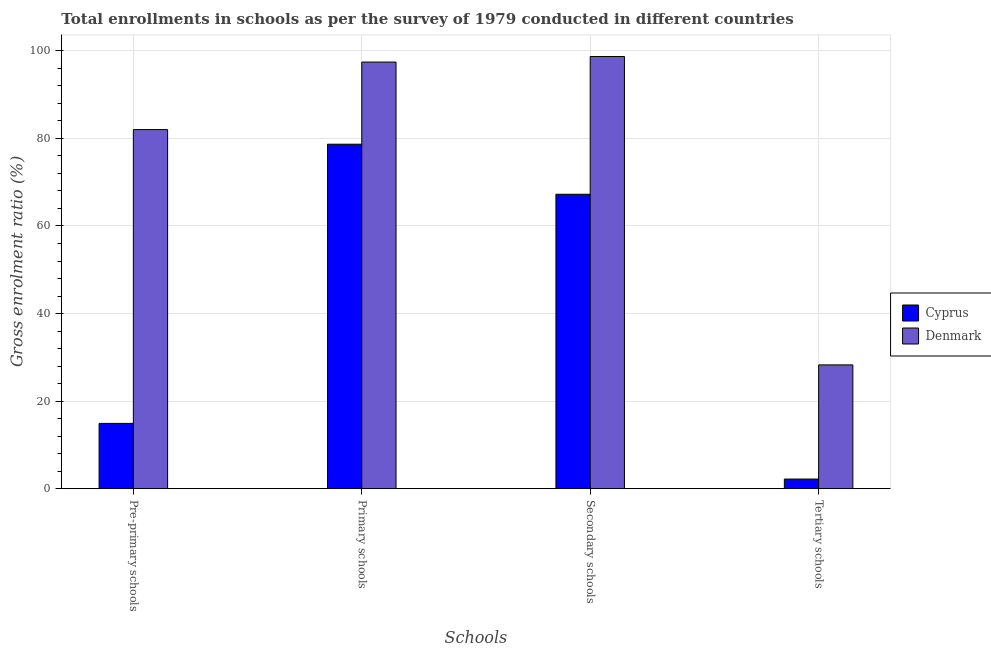Are the number of bars on each tick of the X-axis equal?
Make the answer very short. Yes. How many bars are there on the 3rd tick from the left?
Your response must be concise. 2. How many bars are there on the 1st tick from the right?
Ensure brevity in your answer.  2. What is the label of the 1st group of bars from the left?
Ensure brevity in your answer.  Pre-primary schools. What is the gross enrolment ratio in primary schools in Denmark?
Your answer should be very brief. 97.44. Across all countries, what is the maximum gross enrolment ratio in secondary schools?
Your response must be concise. 98.72. Across all countries, what is the minimum gross enrolment ratio in secondary schools?
Your answer should be very brief. 67.25. In which country was the gross enrolment ratio in tertiary schools maximum?
Provide a short and direct response. Denmark. In which country was the gross enrolment ratio in primary schools minimum?
Ensure brevity in your answer.  Cyprus. What is the total gross enrolment ratio in tertiary schools in the graph?
Provide a succinct answer. 30.47. What is the difference between the gross enrolment ratio in tertiary schools in Cyprus and that in Denmark?
Give a very brief answer. -26.08. What is the difference between the gross enrolment ratio in tertiary schools in Denmark and the gross enrolment ratio in primary schools in Cyprus?
Provide a succinct answer. -50.4. What is the average gross enrolment ratio in secondary schools per country?
Give a very brief answer. 82.98. What is the difference between the gross enrolment ratio in primary schools and gross enrolment ratio in secondary schools in Denmark?
Provide a short and direct response. -1.27. What is the ratio of the gross enrolment ratio in primary schools in Cyprus to that in Denmark?
Your answer should be very brief. 0.81. Is the difference between the gross enrolment ratio in primary schools in Cyprus and Denmark greater than the difference between the gross enrolment ratio in pre-primary schools in Cyprus and Denmark?
Keep it short and to the point. Yes. What is the difference between the highest and the second highest gross enrolment ratio in secondary schools?
Ensure brevity in your answer.  31.47. What is the difference between the highest and the lowest gross enrolment ratio in primary schools?
Your answer should be very brief. 18.77. In how many countries, is the gross enrolment ratio in secondary schools greater than the average gross enrolment ratio in secondary schools taken over all countries?
Give a very brief answer. 1. Is it the case that in every country, the sum of the gross enrolment ratio in tertiary schools and gross enrolment ratio in primary schools is greater than the sum of gross enrolment ratio in pre-primary schools and gross enrolment ratio in secondary schools?
Your response must be concise. No. What does the 1st bar from the right in Tertiary schools represents?
Your answer should be compact. Denmark. Is it the case that in every country, the sum of the gross enrolment ratio in pre-primary schools and gross enrolment ratio in primary schools is greater than the gross enrolment ratio in secondary schools?
Your response must be concise. Yes. Does the graph contain any zero values?
Your answer should be very brief. No. Where does the legend appear in the graph?
Your answer should be very brief. Center right. How are the legend labels stacked?
Offer a very short reply. Vertical. What is the title of the graph?
Keep it short and to the point. Total enrollments in schools as per the survey of 1979 conducted in different countries. Does "Greenland" appear as one of the legend labels in the graph?
Your answer should be very brief. No. What is the label or title of the X-axis?
Your answer should be compact. Schools. What is the Gross enrolment ratio (%) in Cyprus in Pre-primary schools?
Ensure brevity in your answer.  14.91. What is the Gross enrolment ratio (%) in Denmark in Pre-primary schools?
Your response must be concise. 82.02. What is the Gross enrolment ratio (%) of Cyprus in Primary schools?
Your response must be concise. 78.68. What is the Gross enrolment ratio (%) in Denmark in Primary schools?
Give a very brief answer. 97.44. What is the Gross enrolment ratio (%) in Cyprus in Secondary schools?
Provide a short and direct response. 67.25. What is the Gross enrolment ratio (%) in Denmark in Secondary schools?
Offer a terse response. 98.72. What is the Gross enrolment ratio (%) of Cyprus in Tertiary schools?
Offer a terse response. 2.2. What is the Gross enrolment ratio (%) of Denmark in Tertiary schools?
Your answer should be compact. 28.27. Across all Schools, what is the maximum Gross enrolment ratio (%) of Cyprus?
Your answer should be very brief. 78.68. Across all Schools, what is the maximum Gross enrolment ratio (%) in Denmark?
Give a very brief answer. 98.72. Across all Schools, what is the minimum Gross enrolment ratio (%) in Cyprus?
Offer a terse response. 2.2. Across all Schools, what is the minimum Gross enrolment ratio (%) in Denmark?
Ensure brevity in your answer.  28.27. What is the total Gross enrolment ratio (%) in Cyprus in the graph?
Your answer should be compact. 163.03. What is the total Gross enrolment ratio (%) of Denmark in the graph?
Provide a succinct answer. 306.45. What is the difference between the Gross enrolment ratio (%) of Cyprus in Pre-primary schools and that in Primary schools?
Provide a succinct answer. -63.77. What is the difference between the Gross enrolment ratio (%) of Denmark in Pre-primary schools and that in Primary schools?
Provide a succinct answer. -15.42. What is the difference between the Gross enrolment ratio (%) of Cyprus in Pre-primary schools and that in Secondary schools?
Your response must be concise. -52.34. What is the difference between the Gross enrolment ratio (%) in Denmark in Pre-primary schools and that in Secondary schools?
Your response must be concise. -16.7. What is the difference between the Gross enrolment ratio (%) of Cyprus in Pre-primary schools and that in Tertiary schools?
Provide a short and direct response. 12.71. What is the difference between the Gross enrolment ratio (%) of Denmark in Pre-primary schools and that in Tertiary schools?
Offer a very short reply. 53.74. What is the difference between the Gross enrolment ratio (%) in Cyprus in Primary schools and that in Secondary schools?
Keep it short and to the point. 11.43. What is the difference between the Gross enrolment ratio (%) in Denmark in Primary schools and that in Secondary schools?
Offer a terse response. -1.27. What is the difference between the Gross enrolment ratio (%) of Cyprus in Primary schools and that in Tertiary schools?
Make the answer very short. 76.48. What is the difference between the Gross enrolment ratio (%) in Denmark in Primary schools and that in Tertiary schools?
Your answer should be compact. 69.17. What is the difference between the Gross enrolment ratio (%) of Cyprus in Secondary schools and that in Tertiary schools?
Make the answer very short. 65.05. What is the difference between the Gross enrolment ratio (%) in Denmark in Secondary schools and that in Tertiary schools?
Your response must be concise. 70.44. What is the difference between the Gross enrolment ratio (%) of Cyprus in Pre-primary schools and the Gross enrolment ratio (%) of Denmark in Primary schools?
Keep it short and to the point. -82.54. What is the difference between the Gross enrolment ratio (%) of Cyprus in Pre-primary schools and the Gross enrolment ratio (%) of Denmark in Secondary schools?
Provide a short and direct response. -83.81. What is the difference between the Gross enrolment ratio (%) in Cyprus in Pre-primary schools and the Gross enrolment ratio (%) in Denmark in Tertiary schools?
Provide a short and direct response. -13.37. What is the difference between the Gross enrolment ratio (%) in Cyprus in Primary schools and the Gross enrolment ratio (%) in Denmark in Secondary schools?
Give a very brief answer. -20.04. What is the difference between the Gross enrolment ratio (%) in Cyprus in Primary schools and the Gross enrolment ratio (%) in Denmark in Tertiary schools?
Ensure brevity in your answer.  50.4. What is the difference between the Gross enrolment ratio (%) in Cyprus in Secondary schools and the Gross enrolment ratio (%) in Denmark in Tertiary schools?
Provide a succinct answer. 38.97. What is the average Gross enrolment ratio (%) of Cyprus per Schools?
Your response must be concise. 40.76. What is the average Gross enrolment ratio (%) of Denmark per Schools?
Provide a short and direct response. 76.61. What is the difference between the Gross enrolment ratio (%) in Cyprus and Gross enrolment ratio (%) in Denmark in Pre-primary schools?
Provide a short and direct response. -67.11. What is the difference between the Gross enrolment ratio (%) of Cyprus and Gross enrolment ratio (%) of Denmark in Primary schools?
Your answer should be compact. -18.77. What is the difference between the Gross enrolment ratio (%) of Cyprus and Gross enrolment ratio (%) of Denmark in Secondary schools?
Keep it short and to the point. -31.47. What is the difference between the Gross enrolment ratio (%) of Cyprus and Gross enrolment ratio (%) of Denmark in Tertiary schools?
Make the answer very short. -26.08. What is the ratio of the Gross enrolment ratio (%) in Cyprus in Pre-primary schools to that in Primary schools?
Provide a short and direct response. 0.19. What is the ratio of the Gross enrolment ratio (%) in Denmark in Pre-primary schools to that in Primary schools?
Your answer should be compact. 0.84. What is the ratio of the Gross enrolment ratio (%) in Cyprus in Pre-primary schools to that in Secondary schools?
Make the answer very short. 0.22. What is the ratio of the Gross enrolment ratio (%) of Denmark in Pre-primary schools to that in Secondary schools?
Provide a succinct answer. 0.83. What is the ratio of the Gross enrolment ratio (%) of Cyprus in Pre-primary schools to that in Tertiary schools?
Offer a terse response. 6.79. What is the ratio of the Gross enrolment ratio (%) in Denmark in Pre-primary schools to that in Tertiary schools?
Provide a short and direct response. 2.9. What is the ratio of the Gross enrolment ratio (%) in Cyprus in Primary schools to that in Secondary schools?
Provide a succinct answer. 1.17. What is the ratio of the Gross enrolment ratio (%) of Denmark in Primary schools to that in Secondary schools?
Provide a succinct answer. 0.99. What is the ratio of the Gross enrolment ratio (%) in Cyprus in Primary schools to that in Tertiary schools?
Offer a very short reply. 35.82. What is the ratio of the Gross enrolment ratio (%) in Denmark in Primary schools to that in Tertiary schools?
Your answer should be very brief. 3.45. What is the ratio of the Gross enrolment ratio (%) in Cyprus in Secondary schools to that in Tertiary schools?
Ensure brevity in your answer.  30.62. What is the ratio of the Gross enrolment ratio (%) in Denmark in Secondary schools to that in Tertiary schools?
Your response must be concise. 3.49. What is the difference between the highest and the second highest Gross enrolment ratio (%) of Cyprus?
Provide a short and direct response. 11.43. What is the difference between the highest and the second highest Gross enrolment ratio (%) in Denmark?
Your response must be concise. 1.27. What is the difference between the highest and the lowest Gross enrolment ratio (%) of Cyprus?
Keep it short and to the point. 76.48. What is the difference between the highest and the lowest Gross enrolment ratio (%) in Denmark?
Your answer should be compact. 70.44. 